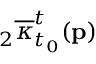Convert formula to latex. <formula><loc_0><loc_0><loc_500><loc_500>{ } _ { 2 } \overline { \kappa } _ { t _ { 0 } } ^ { t } ( p )</formula> 